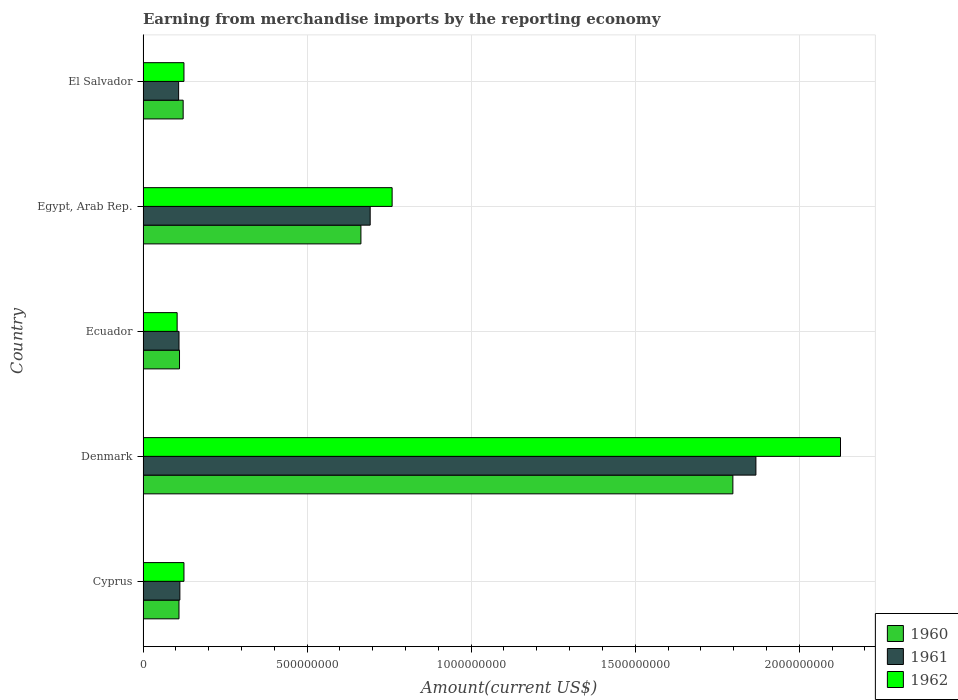How many bars are there on the 3rd tick from the top?
Give a very brief answer. 3. How many bars are there on the 5th tick from the bottom?
Your answer should be very brief. 3. What is the label of the 1st group of bars from the top?
Offer a terse response. El Salvador. In how many cases, is the number of bars for a given country not equal to the number of legend labels?
Provide a succinct answer. 0. What is the amount earned from merchandise imports in 1962 in Denmark?
Your response must be concise. 2.13e+09. Across all countries, what is the maximum amount earned from merchandise imports in 1961?
Give a very brief answer. 1.87e+09. Across all countries, what is the minimum amount earned from merchandise imports in 1960?
Your answer should be very brief. 1.10e+08. In which country was the amount earned from merchandise imports in 1960 minimum?
Your response must be concise. Cyprus. What is the total amount earned from merchandise imports in 1960 in the graph?
Your response must be concise. 2.80e+09. What is the difference between the amount earned from merchandise imports in 1961 in Egypt, Arab Rep. and that in El Salvador?
Your answer should be compact. 5.84e+08. What is the difference between the amount earned from merchandise imports in 1960 in Cyprus and the amount earned from merchandise imports in 1962 in Egypt, Arab Rep.?
Offer a terse response. -6.50e+08. What is the average amount earned from merchandise imports in 1960 per country?
Provide a succinct answer. 5.61e+08. What is the difference between the amount earned from merchandise imports in 1961 and amount earned from merchandise imports in 1962 in Egypt, Arab Rep.?
Your answer should be compact. -6.69e+07. What is the ratio of the amount earned from merchandise imports in 1961 in Cyprus to that in Ecuador?
Your answer should be compact. 1.02. Is the difference between the amount earned from merchandise imports in 1961 in Egypt, Arab Rep. and El Salvador greater than the difference between the amount earned from merchandise imports in 1962 in Egypt, Arab Rep. and El Salvador?
Make the answer very short. No. What is the difference between the highest and the second highest amount earned from merchandise imports in 1960?
Your answer should be compact. 1.13e+09. What is the difference between the highest and the lowest amount earned from merchandise imports in 1960?
Your answer should be very brief. 1.69e+09. Is the sum of the amount earned from merchandise imports in 1960 in Egypt, Arab Rep. and El Salvador greater than the maximum amount earned from merchandise imports in 1961 across all countries?
Your answer should be very brief. No. Is it the case that in every country, the sum of the amount earned from merchandise imports in 1962 and amount earned from merchandise imports in 1961 is greater than the amount earned from merchandise imports in 1960?
Provide a short and direct response. Yes. How many bars are there?
Provide a succinct answer. 15. Are all the bars in the graph horizontal?
Your response must be concise. Yes. How many countries are there in the graph?
Offer a very short reply. 5. What is the difference between two consecutive major ticks on the X-axis?
Your answer should be very brief. 5.00e+08. Are the values on the major ticks of X-axis written in scientific E-notation?
Provide a succinct answer. No. Does the graph contain any zero values?
Make the answer very short. No. Does the graph contain grids?
Make the answer very short. Yes. What is the title of the graph?
Provide a succinct answer. Earning from merchandise imports by the reporting economy. Does "1965" appear as one of the legend labels in the graph?
Provide a short and direct response. No. What is the label or title of the X-axis?
Your response must be concise. Amount(current US$). What is the label or title of the Y-axis?
Offer a very short reply. Country. What is the Amount(current US$) in 1960 in Cyprus?
Provide a succinct answer. 1.10e+08. What is the Amount(current US$) in 1961 in Cyprus?
Provide a succinct answer. 1.12e+08. What is the Amount(current US$) of 1962 in Cyprus?
Ensure brevity in your answer.  1.25e+08. What is the Amount(current US$) in 1960 in Denmark?
Give a very brief answer. 1.80e+09. What is the Amount(current US$) of 1961 in Denmark?
Offer a very short reply. 1.87e+09. What is the Amount(current US$) in 1962 in Denmark?
Offer a very short reply. 2.13e+09. What is the Amount(current US$) in 1960 in Ecuador?
Provide a succinct answer. 1.11e+08. What is the Amount(current US$) in 1961 in Ecuador?
Keep it short and to the point. 1.10e+08. What is the Amount(current US$) in 1962 in Ecuador?
Give a very brief answer. 1.04e+08. What is the Amount(current US$) of 1960 in Egypt, Arab Rep.?
Offer a terse response. 6.64e+08. What is the Amount(current US$) in 1961 in Egypt, Arab Rep.?
Ensure brevity in your answer.  6.92e+08. What is the Amount(current US$) in 1962 in Egypt, Arab Rep.?
Your answer should be compact. 7.59e+08. What is the Amount(current US$) of 1960 in El Salvador?
Keep it short and to the point. 1.22e+08. What is the Amount(current US$) of 1961 in El Salvador?
Your answer should be very brief. 1.08e+08. What is the Amount(current US$) of 1962 in El Salvador?
Keep it short and to the point. 1.25e+08. Across all countries, what is the maximum Amount(current US$) in 1960?
Your response must be concise. 1.80e+09. Across all countries, what is the maximum Amount(current US$) of 1961?
Offer a terse response. 1.87e+09. Across all countries, what is the maximum Amount(current US$) in 1962?
Ensure brevity in your answer.  2.13e+09. Across all countries, what is the minimum Amount(current US$) of 1960?
Offer a very short reply. 1.10e+08. Across all countries, what is the minimum Amount(current US$) in 1961?
Your answer should be compact. 1.08e+08. Across all countries, what is the minimum Amount(current US$) of 1962?
Your answer should be compact. 1.04e+08. What is the total Amount(current US$) in 1960 in the graph?
Your answer should be compact. 2.80e+09. What is the total Amount(current US$) in 1961 in the graph?
Your answer should be very brief. 2.89e+09. What is the total Amount(current US$) in 1962 in the graph?
Make the answer very short. 3.24e+09. What is the difference between the Amount(current US$) of 1960 in Cyprus and that in Denmark?
Your response must be concise. -1.69e+09. What is the difference between the Amount(current US$) in 1961 in Cyprus and that in Denmark?
Provide a succinct answer. -1.76e+09. What is the difference between the Amount(current US$) of 1962 in Cyprus and that in Denmark?
Offer a terse response. -2.00e+09. What is the difference between the Amount(current US$) of 1960 in Cyprus and that in Ecuador?
Your response must be concise. -1.60e+06. What is the difference between the Amount(current US$) in 1961 in Cyprus and that in Ecuador?
Provide a short and direct response. 2.64e+06. What is the difference between the Amount(current US$) of 1962 in Cyprus and that in Ecuador?
Provide a short and direct response. 2.08e+07. What is the difference between the Amount(current US$) of 1960 in Cyprus and that in Egypt, Arab Rep.?
Keep it short and to the point. -5.54e+08. What is the difference between the Amount(current US$) in 1961 in Cyprus and that in Egypt, Arab Rep.?
Offer a very short reply. -5.80e+08. What is the difference between the Amount(current US$) in 1962 in Cyprus and that in Egypt, Arab Rep.?
Make the answer very short. -6.34e+08. What is the difference between the Amount(current US$) of 1960 in Cyprus and that in El Salvador?
Offer a terse response. -1.27e+07. What is the difference between the Amount(current US$) of 1961 in Cyprus and that in El Salvador?
Offer a very short reply. 3.80e+06. What is the difference between the Amount(current US$) in 1962 in Cyprus and that in El Salvador?
Your response must be concise. 0. What is the difference between the Amount(current US$) in 1960 in Denmark and that in Ecuador?
Make the answer very short. 1.69e+09. What is the difference between the Amount(current US$) of 1961 in Denmark and that in Ecuador?
Keep it short and to the point. 1.76e+09. What is the difference between the Amount(current US$) in 1962 in Denmark and that in Ecuador?
Keep it short and to the point. 2.02e+09. What is the difference between the Amount(current US$) in 1960 in Denmark and that in Egypt, Arab Rep.?
Your answer should be compact. 1.13e+09. What is the difference between the Amount(current US$) in 1961 in Denmark and that in Egypt, Arab Rep.?
Make the answer very short. 1.18e+09. What is the difference between the Amount(current US$) of 1962 in Denmark and that in Egypt, Arab Rep.?
Offer a very short reply. 1.37e+09. What is the difference between the Amount(current US$) in 1960 in Denmark and that in El Salvador?
Provide a succinct answer. 1.68e+09. What is the difference between the Amount(current US$) in 1961 in Denmark and that in El Salvador?
Your answer should be very brief. 1.76e+09. What is the difference between the Amount(current US$) in 1962 in Denmark and that in El Salvador?
Offer a very short reply. 2.00e+09. What is the difference between the Amount(current US$) of 1960 in Ecuador and that in Egypt, Arab Rep.?
Give a very brief answer. -5.53e+08. What is the difference between the Amount(current US$) of 1961 in Ecuador and that in Egypt, Arab Rep.?
Ensure brevity in your answer.  -5.83e+08. What is the difference between the Amount(current US$) in 1962 in Ecuador and that in Egypt, Arab Rep.?
Provide a succinct answer. -6.55e+08. What is the difference between the Amount(current US$) of 1960 in Ecuador and that in El Salvador?
Your answer should be compact. -1.11e+07. What is the difference between the Amount(current US$) of 1961 in Ecuador and that in El Salvador?
Offer a terse response. 1.16e+06. What is the difference between the Amount(current US$) of 1962 in Ecuador and that in El Salvador?
Ensure brevity in your answer.  -2.08e+07. What is the difference between the Amount(current US$) in 1960 in Egypt, Arab Rep. and that in El Salvador?
Make the answer very short. 5.42e+08. What is the difference between the Amount(current US$) in 1961 in Egypt, Arab Rep. and that in El Salvador?
Offer a very short reply. 5.84e+08. What is the difference between the Amount(current US$) in 1962 in Egypt, Arab Rep. and that in El Salvador?
Make the answer very short. 6.34e+08. What is the difference between the Amount(current US$) of 1960 in Cyprus and the Amount(current US$) of 1961 in Denmark?
Make the answer very short. -1.76e+09. What is the difference between the Amount(current US$) of 1960 in Cyprus and the Amount(current US$) of 1962 in Denmark?
Your answer should be compact. -2.02e+09. What is the difference between the Amount(current US$) in 1961 in Cyprus and the Amount(current US$) in 1962 in Denmark?
Your answer should be very brief. -2.01e+09. What is the difference between the Amount(current US$) of 1960 in Cyprus and the Amount(current US$) of 1961 in Ecuador?
Provide a succinct answer. -6.00e+04. What is the difference between the Amount(current US$) of 1960 in Cyprus and the Amount(current US$) of 1962 in Ecuador?
Offer a terse response. 5.66e+06. What is the difference between the Amount(current US$) of 1961 in Cyprus and the Amount(current US$) of 1962 in Ecuador?
Offer a very short reply. 8.36e+06. What is the difference between the Amount(current US$) in 1960 in Cyprus and the Amount(current US$) in 1961 in Egypt, Arab Rep.?
Provide a short and direct response. -5.83e+08. What is the difference between the Amount(current US$) in 1960 in Cyprus and the Amount(current US$) in 1962 in Egypt, Arab Rep.?
Provide a short and direct response. -6.50e+08. What is the difference between the Amount(current US$) in 1961 in Cyprus and the Amount(current US$) in 1962 in Egypt, Arab Rep.?
Offer a very short reply. -6.47e+08. What is the difference between the Amount(current US$) of 1960 in Cyprus and the Amount(current US$) of 1961 in El Salvador?
Make the answer very short. 1.10e+06. What is the difference between the Amount(current US$) of 1960 in Cyprus and the Amount(current US$) of 1962 in El Salvador?
Ensure brevity in your answer.  -1.51e+07. What is the difference between the Amount(current US$) of 1961 in Cyprus and the Amount(current US$) of 1962 in El Salvador?
Your response must be concise. -1.24e+07. What is the difference between the Amount(current US$) in 1960 in Denmark and the Amount(current US$) in 1961 in Ecuador?
Offer a terse response. 1.69e+09. What is the difference between the Amount(current US$) of 1960 in Denmark and the Amount(current US$) of 1962 in Ecuador?
Give a very brief answer. 1.69e+09. What is the difference between the Amount(current US$) of 1961 in Denmark and the Amount(current US$) of 1962 in Ecuador?
Provide a short and direct response. 1.76e+09. What is the difference between the Amount(current US$) of 1960 in Denmark and the Amount(current US$) of 1961 in Egypt, Arab Rep.?
Offer a terse response. 1.11e+09. What is the difference between the Amount(current US$) in 1960 in Denmark and the Amount(current US$) in 1962 in Egypt, Arab Rep.?
Provide a succinct answer. 1.04e+09. What is the difference between the Amount(current US$) of 1961 in Denmark and the Amount(current US$) of 1962 in Egypt, Arab Rep.?
Ensure brevity in your answer.  1.11e+09. What is the difference between the Amount(current US$) in 1960 in Denmark and the Amount(current US$) in 1961 in El Salvador?
Offer a terse response. 1.69e+09. What is the difference between the Amount(current US$) of 1960 in Denmark and the Amount(current US$) of 1962 in El Salvador?
Give a very brief answer. 1.67e+09. What is the difference between the Amount(current US$) of 1961 in Denmark and the Amount(current US$) of 1962 in El Salvador?
Offer a terse response. 1.74e+09. What is the difference between the Amount(current US$) in 1960 in Ecuador and the Amount(current US$) in 1961 in Egypt, Arab Rep.?
Your response must be concise. -5.81e+08. What is the difference between the Amount(current US$) in 1960 in Ecuador and the Amount(current US$) in 1962 in Egypt, Arab Rep.?
Make the answer very short. -6.48e+08. What is the difference between the Amount(current US$) of 1961 in Ecuador and the Amount(current US$) of 1962 in Egypt, Arab Rep.?
Offer a terse response. -6.50e+08. What is the difference between the Amount(current US$) of 1960 in Ecuador and the Amount(current US$) of 1961 in El Salvador?
Ensure brevity in your answer.  2.70e+06. What is the difference between the Amount(current US$) in 1960 in Ecuador and the Amount(current US$) in 1962 in El Salvador?
Keep it short and to the point. -1.35e+07. What is the difference between the Amount(current US$) in 1961 in Ecuador and the Amount(current US$) in 1962 in El Salvador?
Your answer should be compact. -1.50e+07. What is the difference between the Amount(current US$) of 1960 in Egypt, Arab Rep. and the Amount(current US$) of 1961 in El Salvador?
Your answer should be very brief. 5.56e+08. What is the difference between the Amount(current US$) in 1960 in Egypt, Arab Rep. and the Amount(current US$) in 1962 in El Salvador?
Provide a succinct answer. 5.39e+08. What is the difference between the Amount(current US$) of 1961 in Egypt, Arab Rep. and the Amount(current US$) of 1962 in El Salvador?
Keep it short and to the point. 5.68e+08. What is the average Amount(current US$) of 1960 per country?
Your answer should be very brief. 5.61e+08. What is the average Amount(current US$) in 1961 per country?
Your answer should be compact. 5.78e+08. What is the average Amount(current US$) in 1962 per country?
Give a very brief answer. 6.48e+08. What is the difference between the Amount(current US$) of 1960 and Amount(current US$) of 1961 in Cyprus?
Give a very brief answer. -2.70e+06. What is the difference between the Amount(current US$) of 1960 and Amount(current US$) of 1962 in Cyprus?
Give a very brief answer. -1.51e+07. What is the difference between the Amount(current US$) in 1961 and Amount(current US$) in 1962 in Cyprus?
Your response must be concise. -1.24e+07. What is the difference between the Amount(current US$) in 1960 and Amount(current US$) in 1961 in Denmark?
Make the answer very short. -7.02e+07. What is the difference between the Amount(current US$) in 1960 and Amount(current US$) in 1962 in Denmark?
Keep it short and to the point. -3.28e+08. What is the difference between the Amount(current US$) of 1961 and Amount(current US$) of 1962 in Denmark?
Your response must be concise. -2.58e+08. What is the difference between the Amount(current US$) in 1960 and Amount(current US$) in 1961 in Ecuador?
Give a very brief answer. 1.54e+06. What is the difference between the Amount(current US$) of 1960 and Amount(current US$) of 1962 in Ecuador?
Offer a very short reply. 7.26e+06. What is the difference between the Amount(current US$) of 1961 and Amount(current US$) of 1962 in Ecuador?
Keep it short and to the point. 5.72e+06. What is the difference between the Amount(current US$) in 1960 and Amount(current US$) in 1961 in Egypt, Arab Rep.?
Provide a succinct answer. -2.82e+07. What is the difference between the Amount(current US$) of 1960 and Amount(current US$) of 1962 in Egypt, Arab Rep.?
Your answer should be very brief. -9.51e+07. What is the difference between the Amount(current US$) of 1961 and Amount(current US$) of 1962 in Egypt, Arab Rep.?
Provide a short and direct response. -6.69e+07. What is the difference between the Amount(current US$) of 1960 and Amount(current US$) of 1961 in El Salvador?
Ensure brevity in your answer.  1.38e+07. What is the difference between the Amount(current US$) of 1960 and Amount(current US$) of 1962 in El Salvador?
Offer a terse response. -2.40e+06. What is the difference between the Amount(current US$) of 1961 and Amount(current US$) of 1962 in El Salvador?
Ensure brevity in your answer.  -1.62e+07. What is the ratio of the Amount(current US$) of 1960 in Cyprus to that in Denmark?
Keep it short and to the point. 0.06. What is the ratio of the Amount(current US$) in 1961 in Cyprus to that in Denmark?
Provide a short and direct response. 0.06. What is the ratio of the Amount(current US$) of 1962 in Cyprus to that in Denmark?
Ensure brevity in your answer.  0.06. What is the ratio of the Amount(current US$) of 1960 in Cyprus to that in Ecuador?
Keep it short and to the point. 0.99. What is the ratio of the Amount(current US$) in 1961 in Cyprus to that in Ecuador?
Give a very brief answer. 1.02. What is the ratio of the Amount(current US$) of 1962 in Cyprus to that in Ecuador?
Keep it short and to the point. 1.2. What is the ratio of the Amount(current US$) in 1960 in Cyprus to that in Egypt, Arab Rep.?
Offer a very short reply. 0.16. What is the ratio of the Amount(current US$) in 1961 in Cyprus to that in Egypt, Arab Rep.?
Make the answer very short. 0.16. What is the ratio of the Amount(current US$) of 1962 in Cyprus to that in Egypt, Arab Rep.?
Provide a succinct answer. 0.16. What is the ratio of the Amount(current US$) in 1960 in Cyprus to that in El Salvador?
Provide a succinct answer. 0.9. What is the ratio of the Amount(current US$) of 1961 in Cyprus to that in El Salvador?
Provide a short and direct response. 1.04. What is the ratio of the Amount(current US$) in 1962 in Cyprus to that in El Salvador?
Ensure brevity in your answer.  1. What is the ratio of the Amount(current US$) of 1960 in Denmark to that in Ecuador?
Your answer should be very brief. 16.18. What is the ratio of the Amount(current US$) in 1961 in Denmark to that in Ecuador?
Your answer should be very brief. 17.05. What is the ratio of the Amount(current US$) in 1962 in Denmark to that in Ecuador?
Your answer should be compact. 20.47. What is the ratio of the Amount(current US$) in 1960 in Denmark to that in Egypt, Arab Rep.?
Your response must be concise. 2.71. What is the ratio of the Amount(current US$) of 1961 in Denmark to that in Egypt, Arab Rep.?
Offer a terse response. 2.7. What is the ratio of the Amount(current US$) of 1962 in Denmark to that in Egypt, Arab Rep.?
Make the answer very short. 2.8. What is the ratio of the Amount(current US$) of 1960 in Denmark to that in El Salvador?
Your response must be concise. 14.71. What is the ratio of the Amount(current US$) of 1961 in Denmark to that in El Salvador?
Offer a terse response. 17.23. What is the ratio of the Amount(current US$) in 1962 in Denmark to that in El Salvador?
Your answer should be very brief. 17.06. What is the ratio of the Amount(current US$) in 1960 in Ecuador to that in Egypt, Arab Rep.?
Provide a succinct answer. 0.17. What is the ratio of the Amount(current US$) of 1961 in Ecuador to that in Egypt, Arab Rep.?
Make the answer very short. 0.16. What is the ratio of the Amount(current US$) of 1962 in Ecuador to that in Egypt, Arab Rep.?
Give a very brief answer. 0.14. What is the ratio of the Amount(current US$) in 1960 in Ecuador to that in El Salvador?
Provide a short and direct response. 0.91. What is the ratio of the Amount(current US$) of 1961 in Ecuador to that in El Salvador?
Provide a short and direct response. 1.01. What is the ratio of the Amount(current US$) of 1962 in Ecuador to that in El Salvador?
Your response must be concise. 0.83. What is the ratio of the Amount(current US$) in 1960 in Egypt, Arab Rep. to that in El Salvador?
Give a very brief answer. 5.43. What is the ratio of the Amount(current US$) in 1961 in Egypt, Arab Rep. to that in El Salvador?
Offer a terse response. 6.39. What is the ratio of the Amount(current US$) of 1962 in Egypt, Arab Rep. to that in El Salvador?
Give a very brief answer. 6.09. What is the difference between the highest and the second highest Amount(current US$) of 1960?
Give a very brief answer. 1.13e+09. What is the difference between the highest and the second highest Amount(current US$) of 1961?
Your answer should be very brief. 1.18e+09. What is the difference between the highest and the second highest Amount(current US$) of 1962?
Provide a succinct answer. 1.37e+09. What is the difference between the highest and the lowest Amount(current US$) of 1960?
Provide a succinct answer. 1.69e+09. What is the difference between the highest and the lowest Amount(current US$) in 1961?
Your answer should be compact. 1.76e+09. What is the difference between the highest and the lowest Amount(current US$) of 1962?
Your response must be concise. 2.02e+09. 